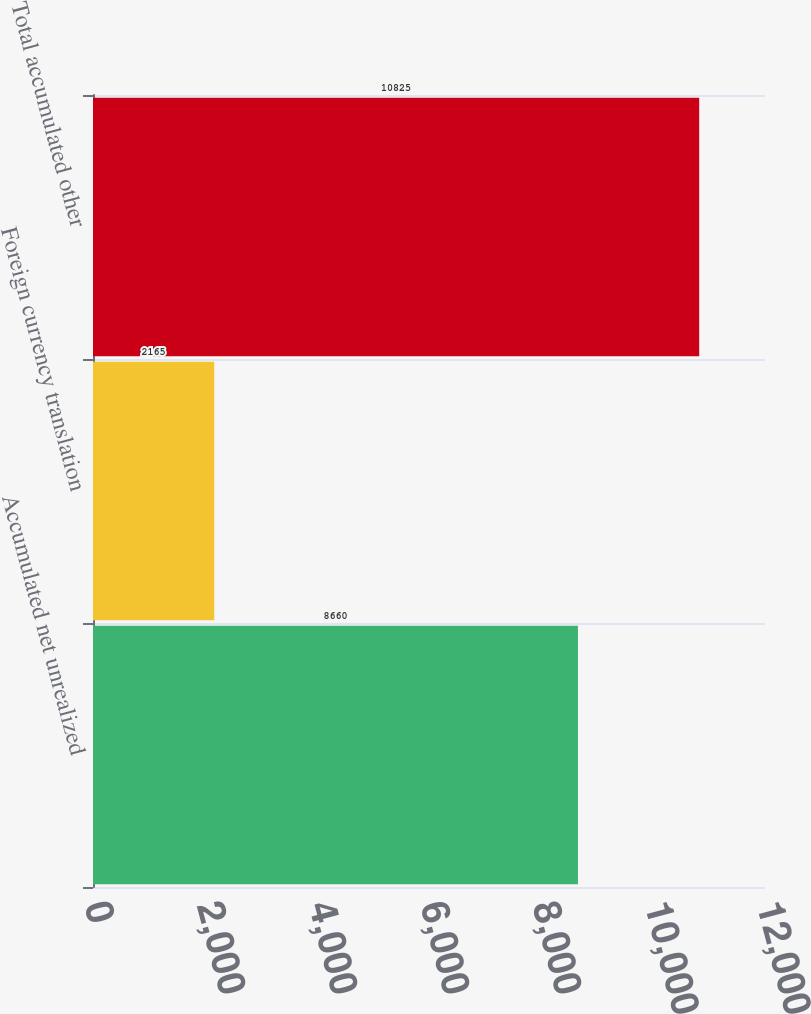Convert chart to OTSL. <chart><loc_0><loc_0><loc_500><loc_500><bar_chart><fcel>Accumulated net unrealized<fcel>Foreign currency translation<fcel>Total accumulated other<nl><fcel>8660<fcel>2165<fcel>10825<nl></chart> 